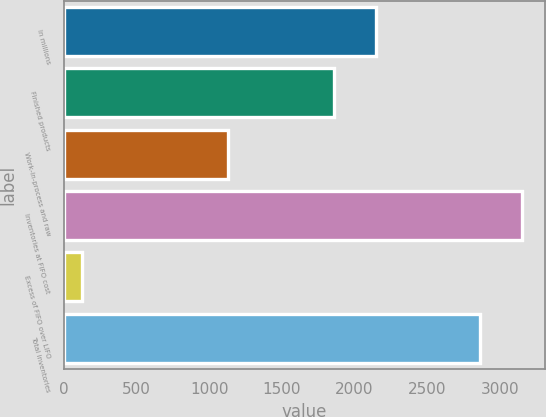<chart> <loc_0><loc_0><loc_500><loc_500><bar_chart><fcel>In millions<fcel>Finished products<fcel>Work-in-process and raw<fcel>Inventories at FIFO cost<fcel>Excess of FIFO over LIFO<fcel>Total inventories<nl><fcel>2145.6<fcel>1859<fcel>1129<fcel>3152.6<fcel>122<fcel>2866<nl></chart> 